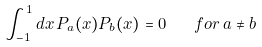Convert formula to latex. <formula><loc_0><loc_0><loc_500><loc_500>\int _ { - 1 } ^ { 1 } d x \, P _ { a } ( x ) P _ { b } ( x ) = 0 \quad f o r \, a \neq b</formula> 